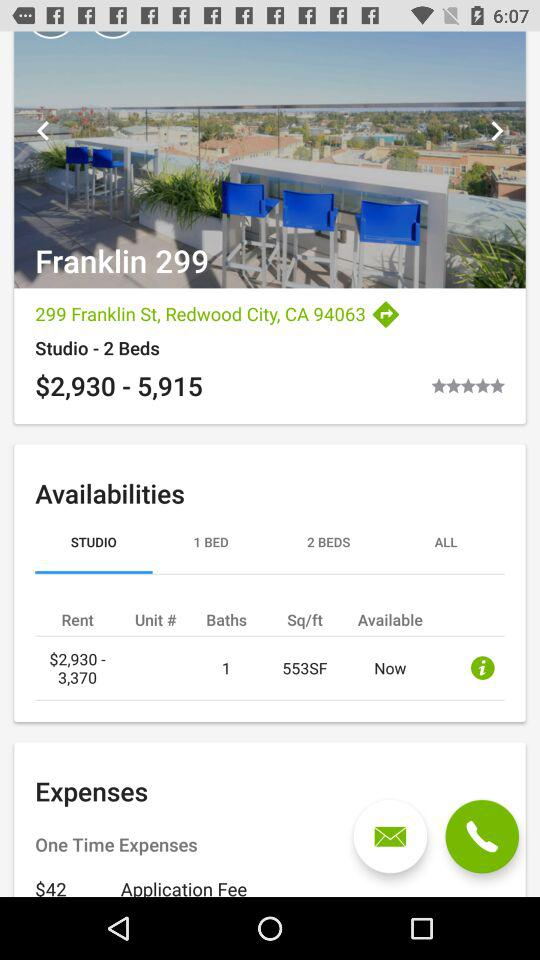What is the number of beds? The number of beds is 2. 